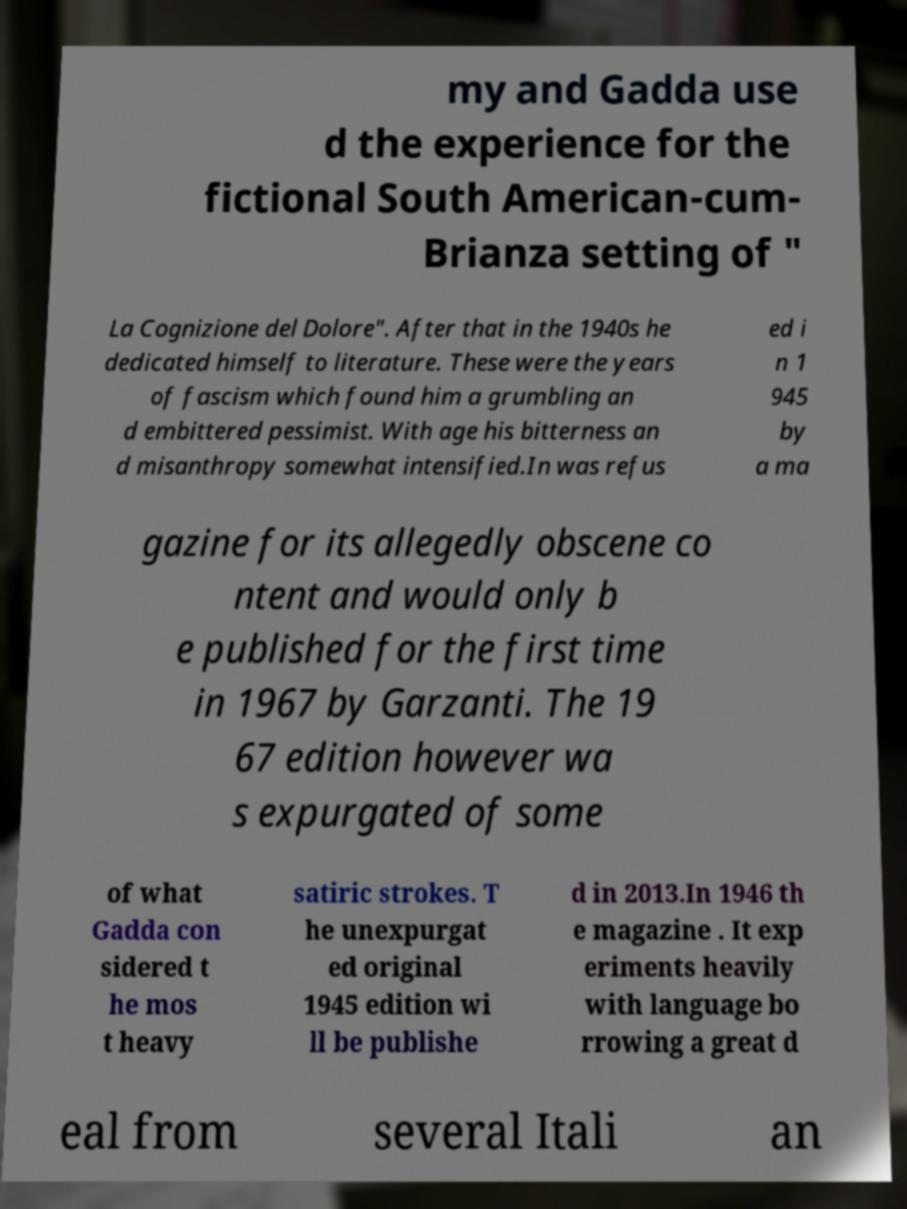What messages or text are displayed in this image? I need them in a readable, typed format. my and Gadda use d the experience for the fictional South American-cum- Brianza setting of " La Cognizione del Dolore". After that in the 1940s he dedicated himself to literature. These were the years of fascism which found him a grumbling an d embittered pessimist. With age his bitterness an d misanthropy somewhat intensified.In was refus ed i n 1 945 by a ma gazine for its allegedly obscene co ntent and would only b e published for the first time in 1967 by Garzanti. The 19 67 edition however wa s expurgated of some of what Gadda con sidered t he mos t heavy satiric strokes. T he unexpurgat ed original 1945 edition wi ll be publishe d in 2013.In 1946 th e magazine . It exp eriments heavily with language bo rrowing a great d eal from several Itali an 